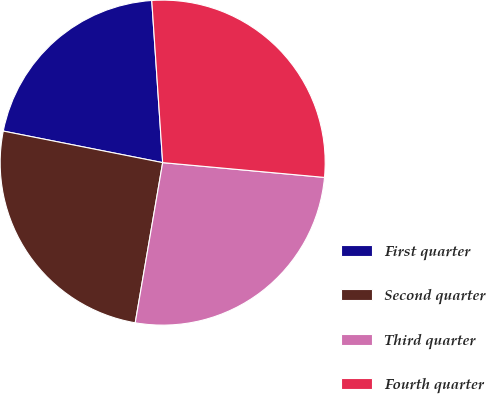Convert chart. <chart><loc_0><loc_0><loc_500><loc_500><pie_chart><fcel>First quarter<fcel>Second quarter<fcel>Third quarter<fcel>Fourth quarter<nl><fcel>20.82%<fcel>25.41%<fcel>26.25%<fcel>27.52%<nl></chart> 